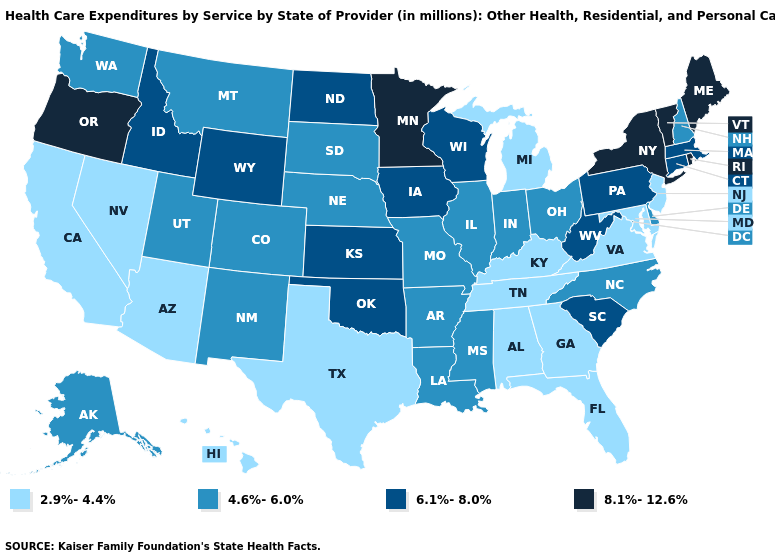What is the value of Oklahoma?
Keep it brief. 6.1%-8.0%. Name the states that have a value in the range 2.9%-4.4%?
Keep it brief. Alabama, Arizona, California, Florida, Georgia, Hawaii, Kentucky, Maryland, Michigan, Nevada, New Jersey, Tennessee, Texas, Virginia. Name the states that have a value in the range 4.6%-6.0%?
Keep it brief. Alaska, Arkansas, Colorado, Delaware, Illinois, Indiana, Louisiana, Mississippi, Missouri, Montana, Nebraska, New Hampshire, New Mexico, North Carolina, Ohio, South Dakota, Utah, Washington. Among the states that border New Mexico , does Texas have the lowest value?
Give a very brief answer. Yes. Among the states that border Wyoming , which have the lowest value?
Short answer required. Colorado, Montana, Nebraska, South Dakota, Utah. What is the value of Missouri?
Be succinct. 4.6%-6.0%. Among the states that border Delaware , which have the highest value?
Answer briefly. Pennsylvania. Name the states that have a value in the range 8.1%-12.6%?
Quick response, please. Maine, Minnesota, New York, Oregon, Rhode Island, Vermont. Does Vermont have the highest value in the USA?
Short answer required. Yes. Does the map have missing data?
Write a very short answer. No. Does Virginia have the same value as Maine?
Keep it brief. No. Does Alaska have the same value as Colorado?
Give a very brief answer. Yes. What is the value of Indiana?
Write a very short answer. 4.6%-6.0%. Name the states that have a value in the range 4.6%-6.0%?
Short answer required. Alaska, Arkansas, Colorado, Delaware, Illinois, Indiana, Louisiana, Mississippi, Missouri, Montana, Nebraska, New Hampshire, New Mexico, North Carolina, Ohio, South Dakota, Utah, Washington. What is the lowest value in the MidWest?
Keep it brief. 2.9%-4.4%. 